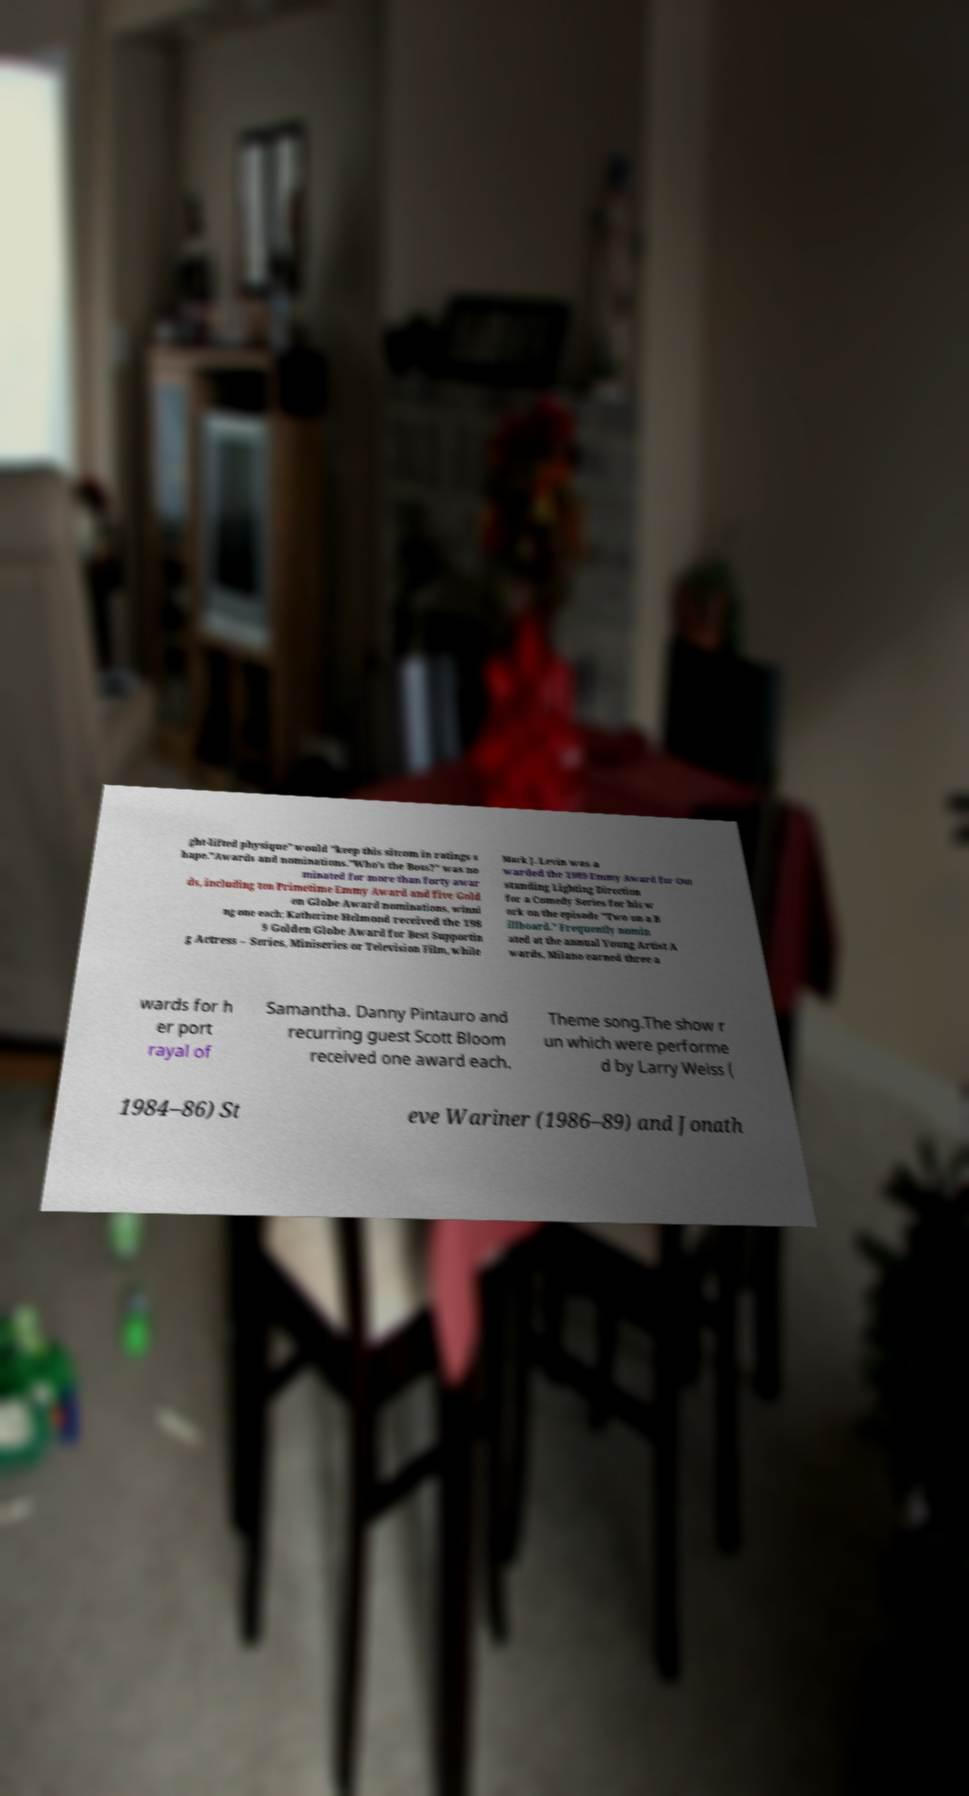Please identify and transcribe the text found in this image. ght-lifted physique" would "keep this sitcom in ratings s hape."Awards and nominations."Who's the Boss?" was no minated for more than forty awar ds, including ten Primetime Emmy Award and five Gold en Globe Award nominations, winni ng one each; Katherine Helmond received the 198 9 Golden Globe Award for Best Supportin g Actress – Series, Miniseries or Television Film, while Mark J. Levin was a warded the 1989 Emmy Award for Out standing Lighting Direction for a Comedy Series for his w ork on the episode "Two on a B illboard." Frequently nomin ated at the annual Young Artist A wards, Milano earned three a wards for h er port rayal of Samantha. Danny Pintauro and recurring guest Scott Bloom received one award each. Theme song.The show r un which were performe d by Larry Weiss ( 1984–86) St eve Wariner (1986–89) and Jonath 